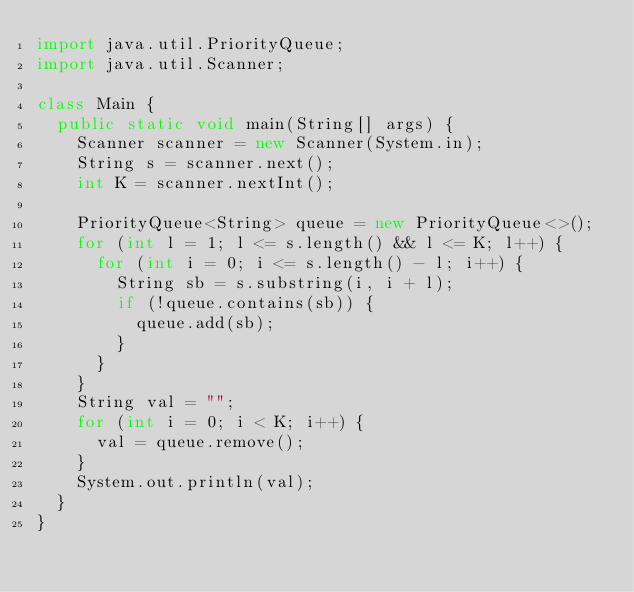Convert code to text. <code><loc_0><loc_0><loc_500><loc_500><_Java_>import java.util.PriorityQueue;
import java.util.Scanner;

class Main {
  public static void main(String[] args) {
    Scanner scanner = new Scanner(System.in);
    String s = scanner.next();
    int K = scanner.nextInt();

    PriorityQueue<String> queue = new PriorityQueue<>();
    for (int l = 1; l <= s.length() && l <= K; l++) {
      for (int i = 0; i <= s.length() - l; i++) {
        String sb = s.substring(i, i + l);
        if (!queue.contains(sb)) {
          queue.add(sb);
        }
      }
    }
    String val = "";
    for (int i = 0; i < K; i++) {
      val = queue.remove();
    }
    System.out.println(val);
  }
}
</code> 